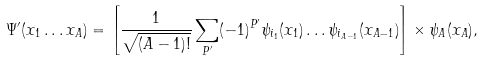<formula> <loc_0><loc_0><loc_500><loc_500>\Psi ^ { \prime } ( x _ { 1 } \dots x _ { A } ) = \left [ { \frac { 1 } { \sqrt { ( A - 1 ) ! } } } \sum _ { P ^ { \prime } } ( - 1 ) ^ { P ^ { \prime } } \psi _ { i _ { 1 } } ( x _ { 1 } ) \dots \psi _ { i _ { A - 1 } } ( x _ { A - 1 } ) \right ] \times \psi _ { A } ( x _ { A } ) ,</formula> 